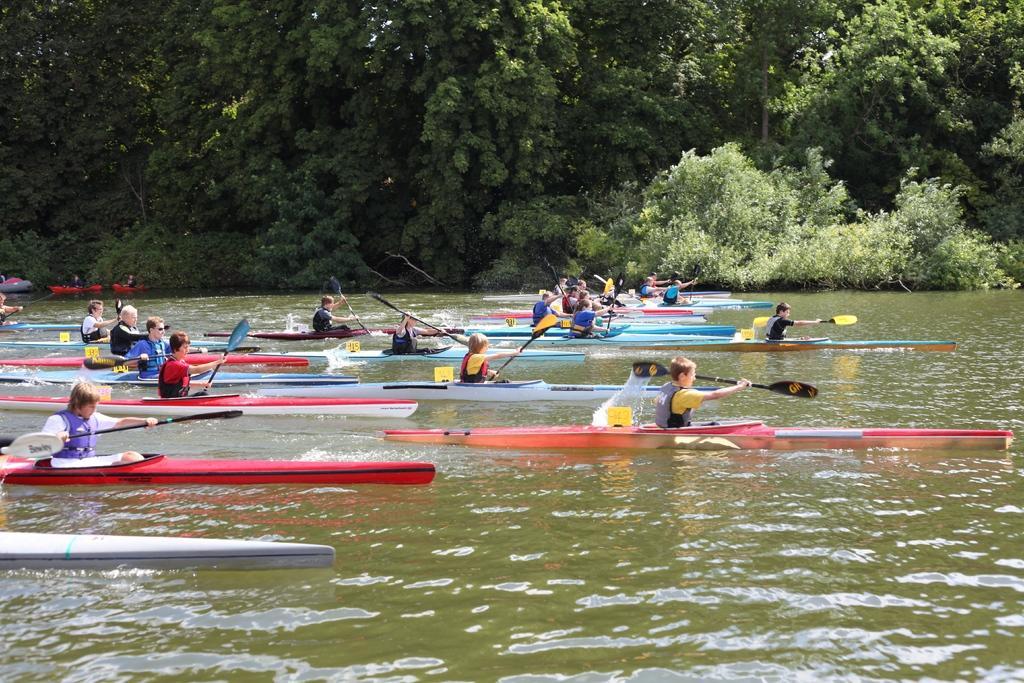Describe this image in one or two sentences. Here few persons are travelling in the boats. This is water and these are the green trees. 